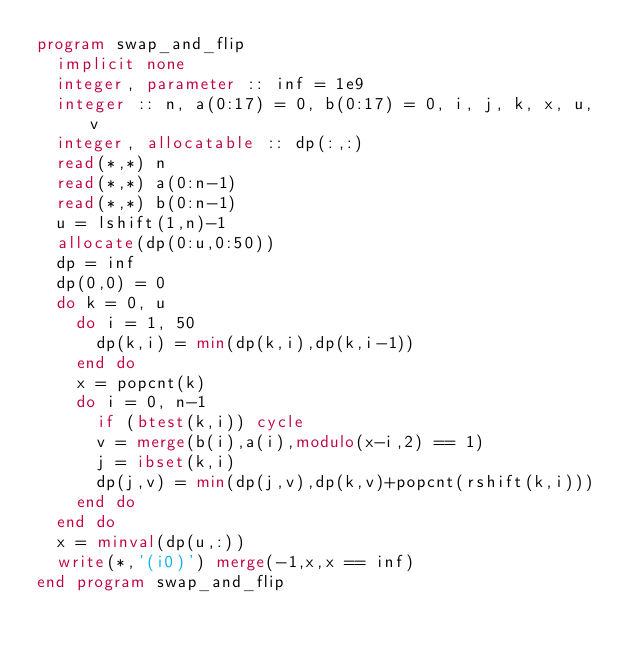Convert code to text. <code><loc_0><loc_0><loc_500><loc_500><_FORTRAN_>program swap_and_flip
  implicit none
  integer, parameter :: inf = 1e9
  integer :: n, a(0:17) = 0, b(0:17) = 0, i, j, k, x, u, v
  integer, allocatable :: dp(:,:)
  read(*,*) n
  read(*,*) a(0:n-1)
  read(*,*) b(0:n-1)
  u = lshift(1,n)-1
  allocate(dp(0:u,0:50))
  dp = inf
  dp(0,0) = 0
  do k = 0, u
    do i = 1, 50
      dp(k,i) = min(dp(k,i),dp(k,i-1))
    end do
    x = popcnt(k)
    do i = 0, n-1
      if (btest(k,i)) cycle
      v = merge(b(i),a(i),modulo(x-i,2) == 1)
      j = ibset(k,i)
      dp(j,v) = min(dp(j,v),dp(k,v)+popcnt(rshift(k,i)))
    end do
  end do
  x = minval(dp(u,:))
  write(*,'(i0)') merge(-1,x,x == inf)
end program swap_and_flip</code> 